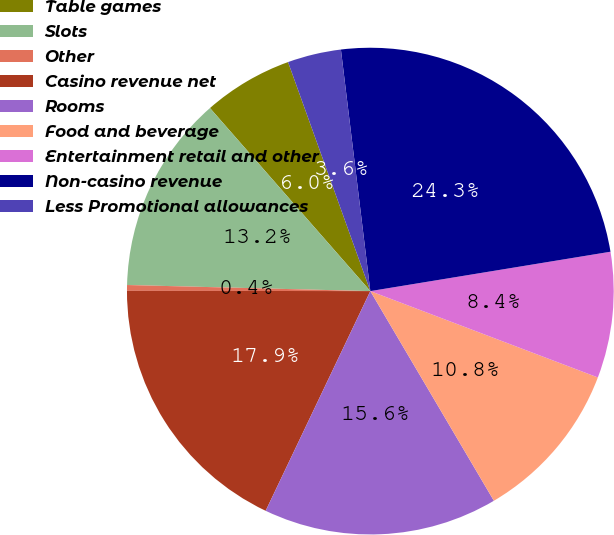Convert chart to OTSL. <chart><loc_0><loc_0><loc_500><loc_500><pie_chart><fcel>Table games<fcel>Slots<fcel>Other<fcel>Casino revenue net<fcel>Rooms<fcel>Food and beverage<fcel>Entertainment retail and other<fcel>Non-casino revenue<fcel>Less Promotional allowances<nl><fcel>5.96%<fcel>13.15%<fcel>0.38%<fcel>17.94%<fcel>15.55%<fcel>10.75%<fcel>8.36%<fcel>24.34%<fcel>3.56%<nl></chart> 